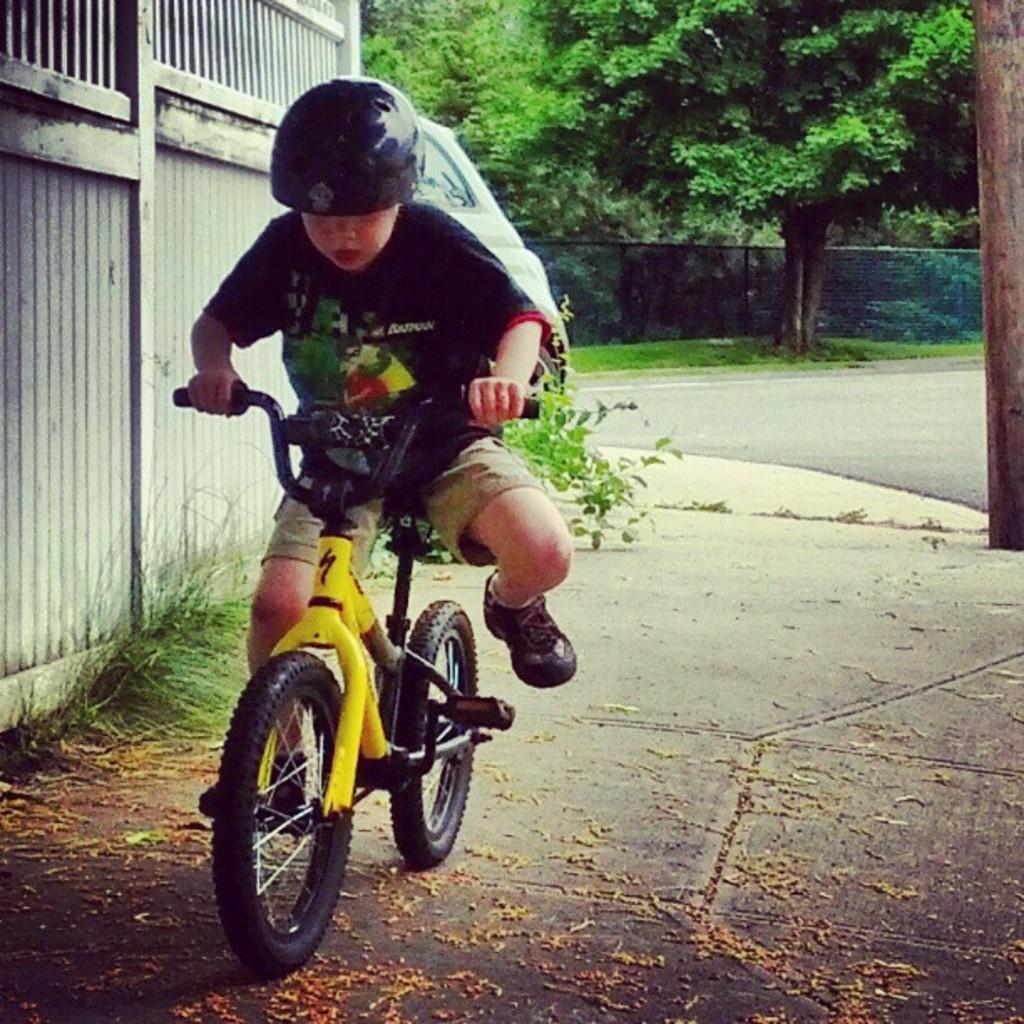Could you give a brief overview of what you see in this image? This image is clicked outside. On the left there is a Boy wearing helmet and riding bicycle with his one leg on the pedal and the another leg in the air, behind him there is a Car. On the left there is a metal gate and some grass on the ground. In the background there are some Trees and we can see the road. 